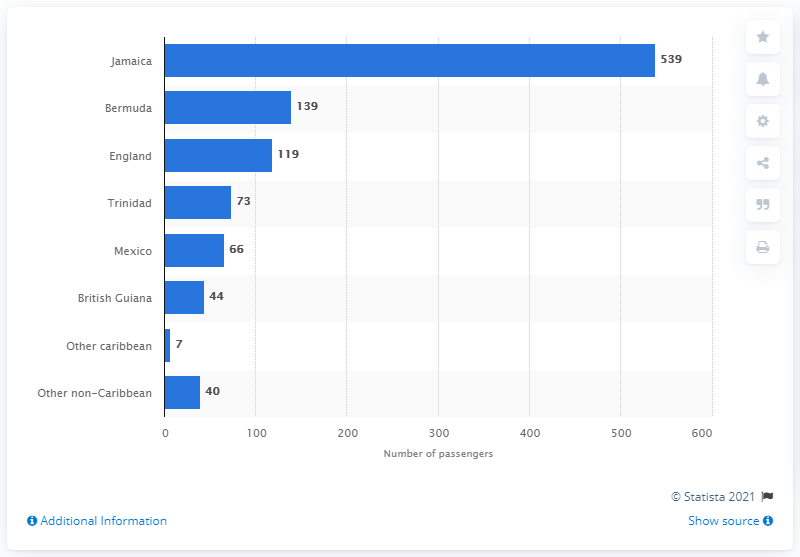List a handful of essential elements in this visual. The last country of residence for passengers of the HMT Empire Windrush was Jamaica. 